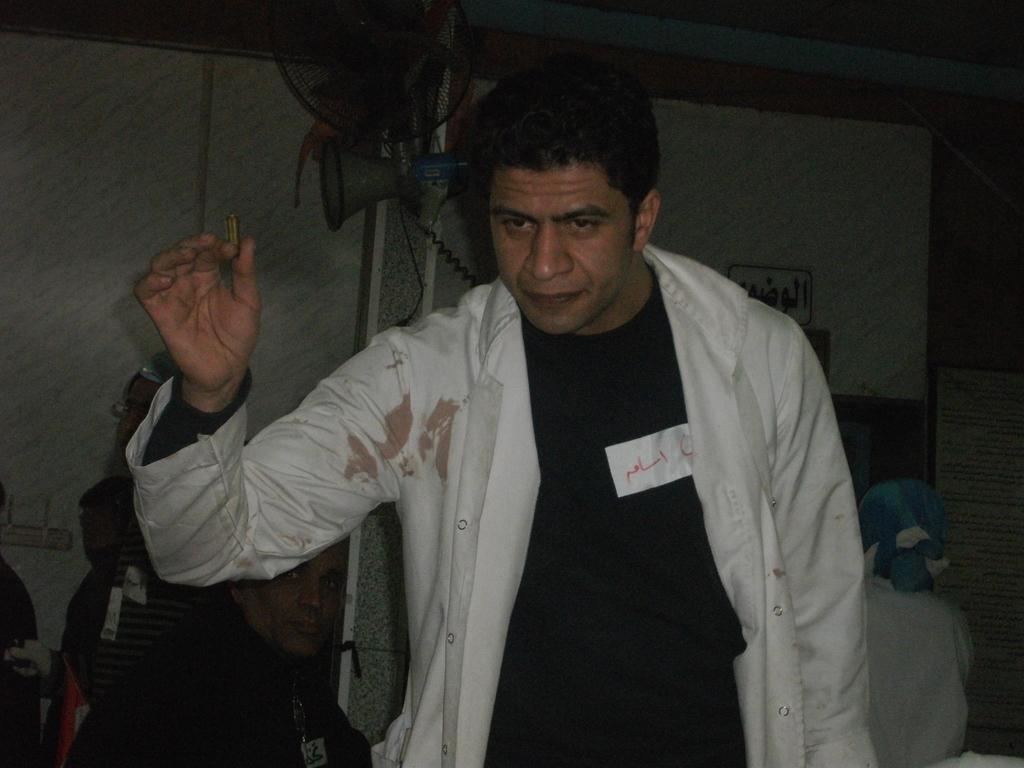In one or two sentences, can you explain what this image depicts? In this picture there is a man who is wearing t-shirt and shirt. Beside him I can see some persons who are sitting on the chair. In the back I can see the fan and speaker which are placed on this pipe. Beside that I can see the partition. In the top right corner I can see the roof. 